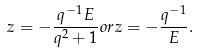Convert formula to latex. <formula><loc_0><loc_0><loc_500><loc_500>z = - \frac { q ^ { - 1 } E } { q ^ { 2 } + 1 } o r z = - \frac { q ^ { - 1 } } { E } .</formula> 